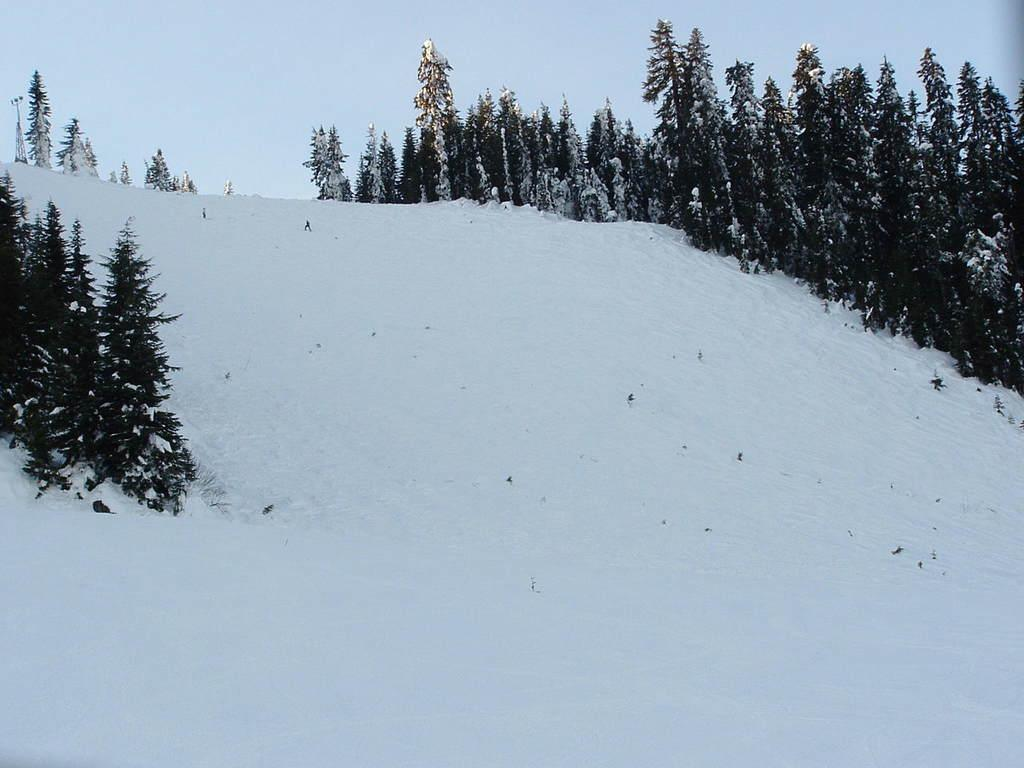What type of vegetation can be seen in the image? There are many trees in the image. What is the weather like in the image? There is snow visible in the image, indicating a cold or wintery environment. What else is visible in the image besides the trees and snow? The sky is visible in the image. What type of lamp is present in the image? There is no lamp present in the image. What level of excitement can be seen in the image? The image does not depict any emotions or levels of excitement; it primarily features trees, snow, and the sky. 